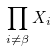Convert formula to latex. <formula><loc_0><loc_0><loc_500><loc_500>\prod _ { i \ne \beta } X _ { i }</formula> 